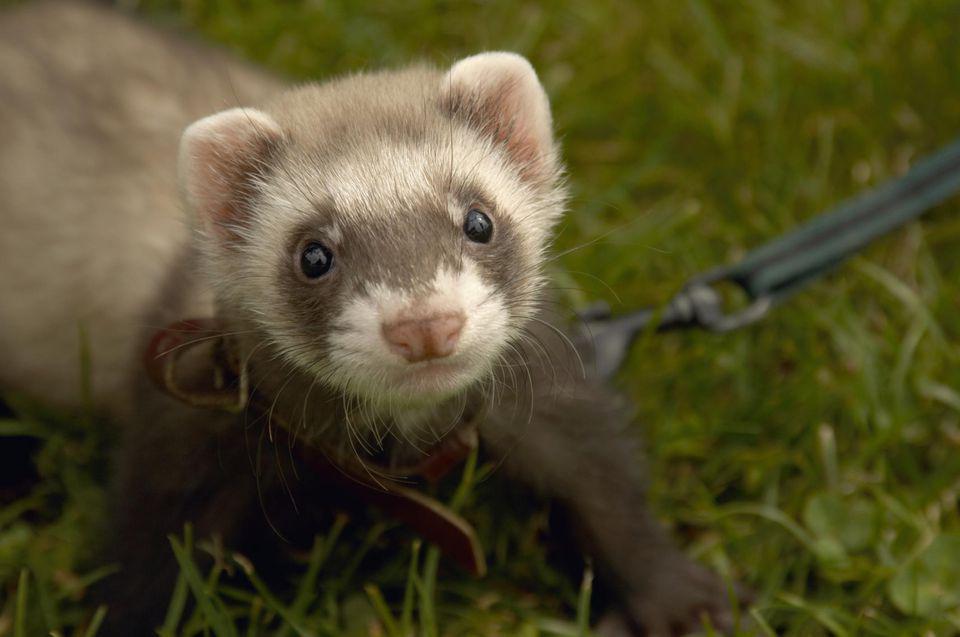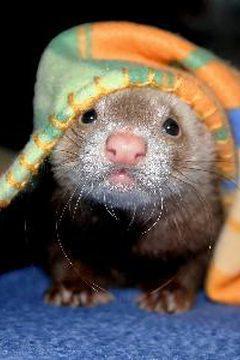The first image is the image on the left, the second image is the image on the right. Assess this claim about the two images: "The left image includes at least one ferret standing on all fours, and the right image contains two side-by-side ferrets with at least one having sleepy eyes.". Correct or not? Answer yes or no. No. 